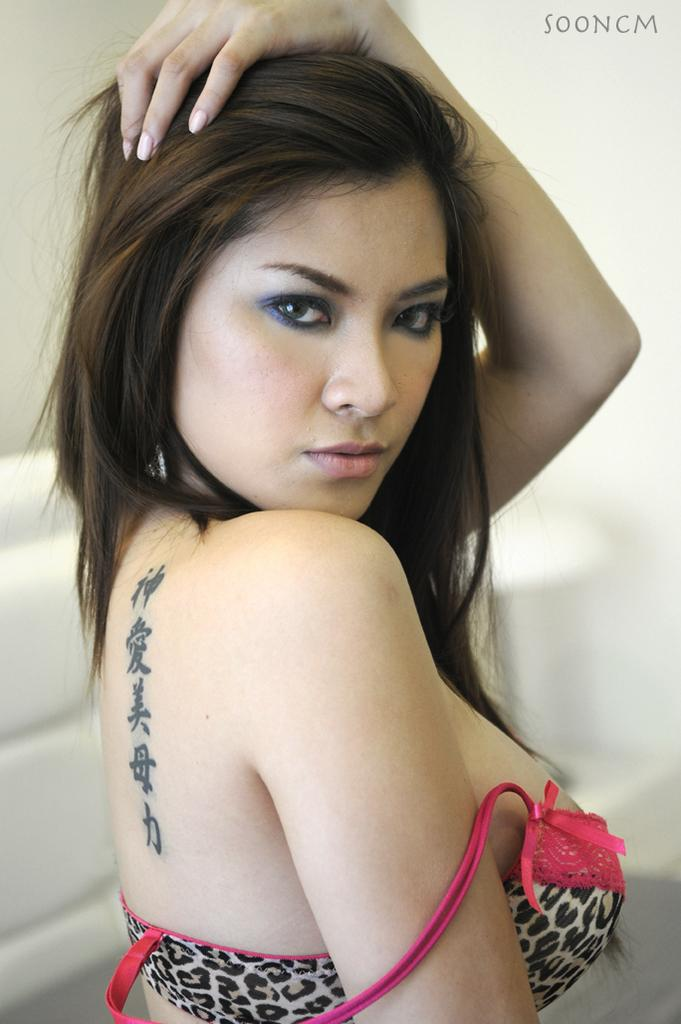Who is the main subject in the image? There is a woman in the image. What color is the background of the image? The background of the image is white. Is there any additional text or symbol in the image? Yes, there is a watermark at the top right side of the image. How many planes are visible in the image? There are no planes visible in the image; it features a woman with a white background and a watermark. What type of loss is depicted in the image? There is no depiction of loss in the image; it features a woman with a white background and a watermark. 